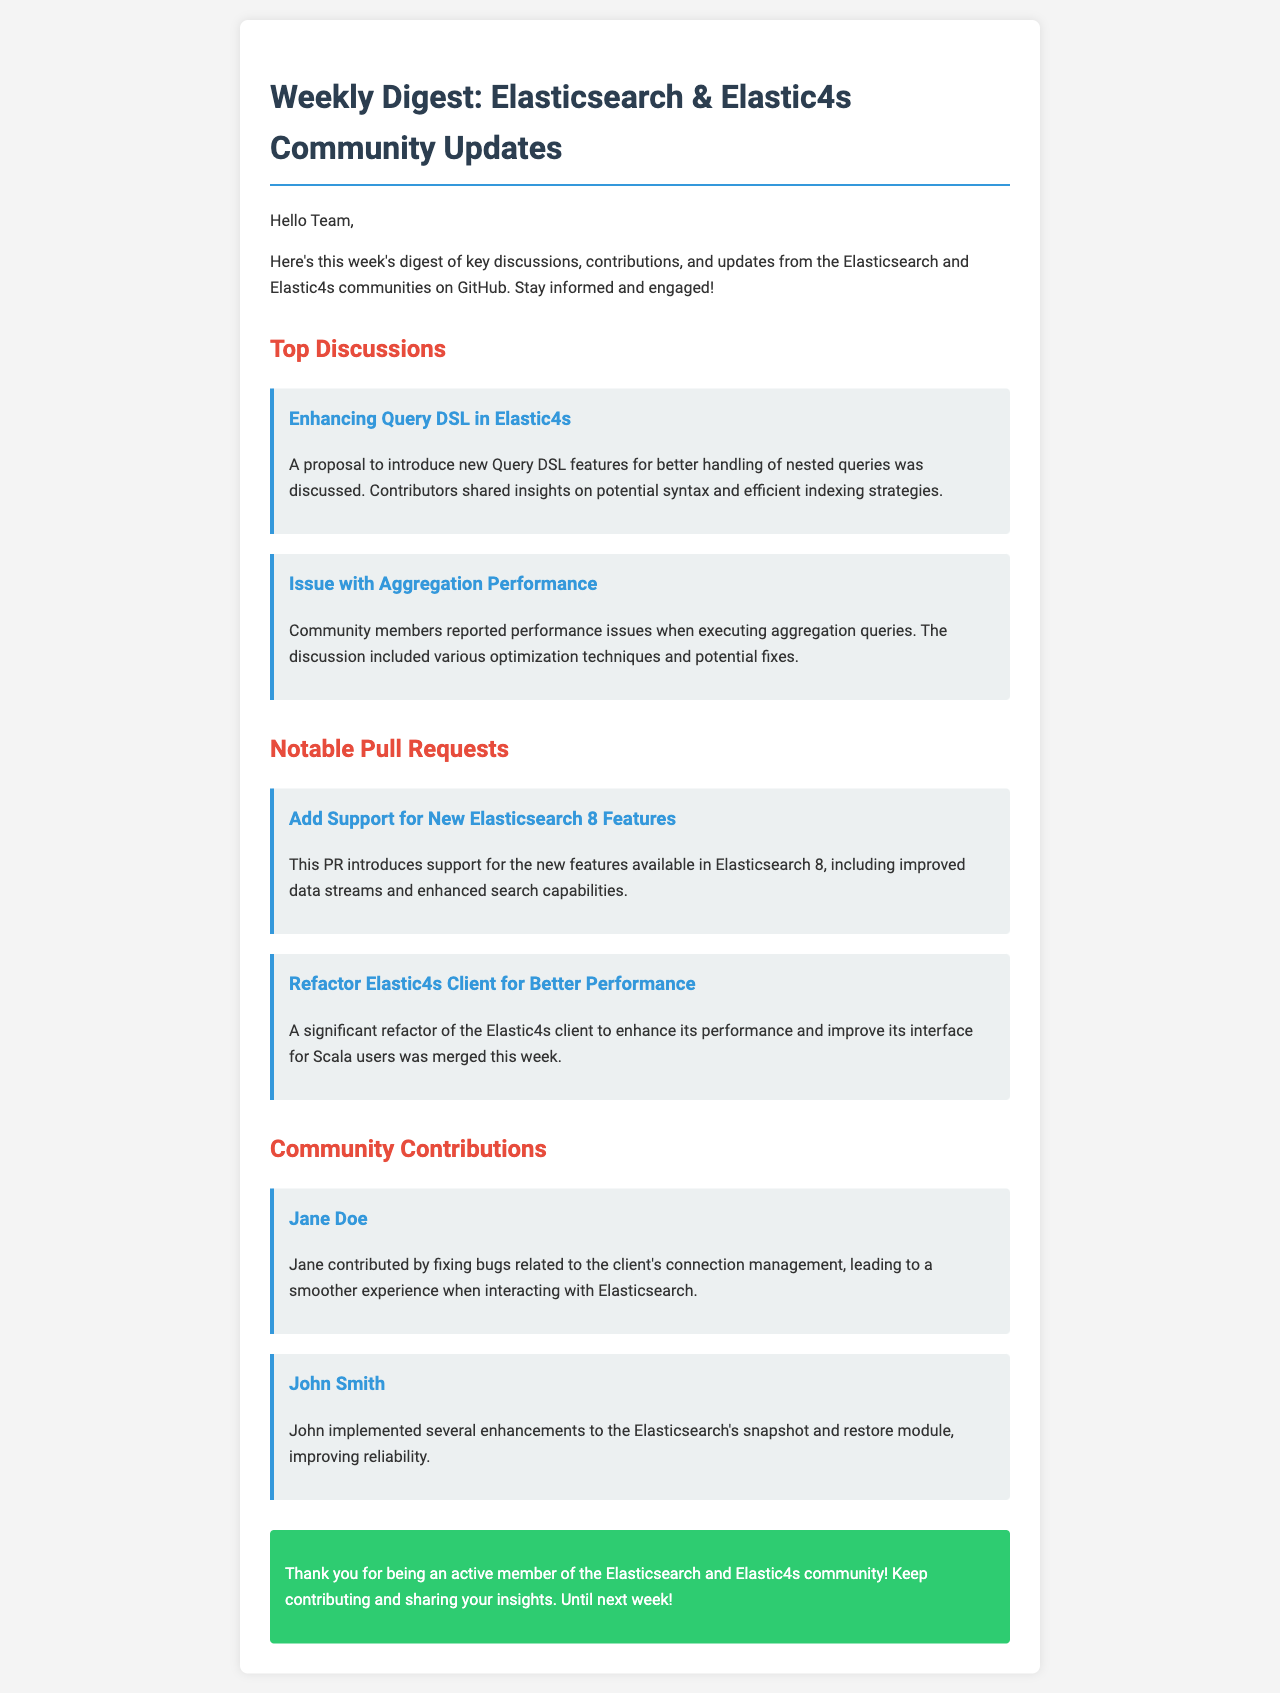What is the title of the document? The title is indicated in the HTML head section of the document.
Answer: Weekly Digest: Elasticsearch & Elastic4s Community Updates How many top discussions are listed? The number of discussions is given in the section labeled "Top Discussions."
Answer: 2 Who contributed to fixing bugs related to the client's connection management? The document mentions community contributions with specific names.
Answer: Jane Doe What issue was discussed related to aggregation performance? The problem discussed is specified in the details of a top discussion.
Answer: Performance issues when executing aggregation queries Which pull request introduces support for Elasticsearch 8 features? The pull request title provides specific information about its content.
Answer: Add Support for New Elasticsearch 8 Features What color is the conclusion section? The document describes the style of the conclusion section, including its background color.
Answer: Green How many notable pull requests are mentioned? The count can be derived from the section labeled "Notable Pull Requests."
Answer: 2 Which community member improved the snapshot and restore module? This information is typically found in the community contributions section.
Answer: John Smith 